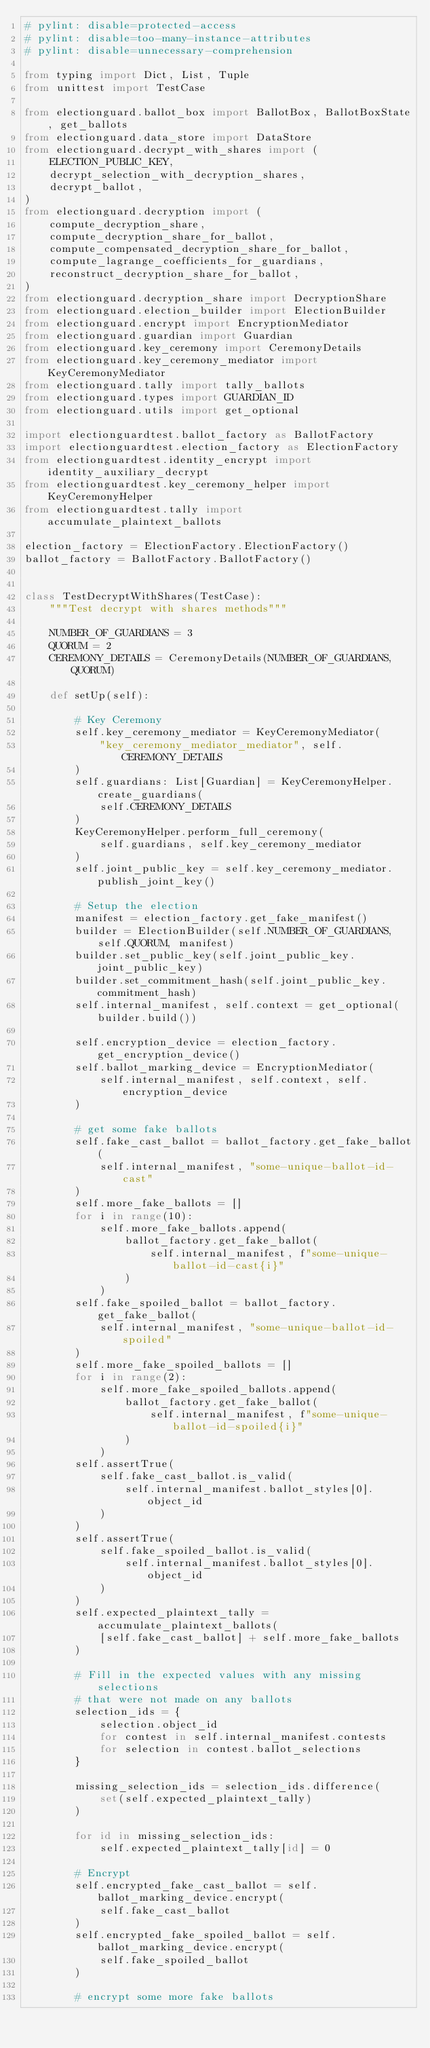<code> <loc_0><loc_0><loc_500><loc_500><_Python_># pylint: disable=protected-access
# pylint: disable=too-many-instance-attributes
# pylint: disable=unnecessary-comprehension

from typing import Dict, List, Tuple
from unittest import TestCase

from electionguard.ballot_box import BallotBox, BallotBoxState, get_ballots
from electionguard.data_store import DataStore
from electionguard.decrypt_with_shares import (
    ELECTION_PUBLIC_KEY,
    decrypt_selection_with_decryption_shares,
    decrypt_ballot,
)
from electionguard.decryption import (
    compute_decryption_share,
    compute_decryption_share_for_ballot,
    compute_compensated_decryption_share_for_ballot,
    compute_lagrange_coefficients_for_guardians,
    reconstruct_decryption_share_for_ballot,
)
from electionguard.decryption_share import DecryptionShare
from electionguard.election_builder import ElectionBuilder
from electionguard.encrypt import EncryptionMediator
from electionguard.guardian import Guardian
from electionguard.key_ceremony import CeremonyDetails
from electionguard.key_ceremony_mediator import KeyCeremonyMediator
from electionguard.tally import tally_ballots
from electionguard.types import GUARDIAN_ID
from electionguard.utils import get_optional

import electionguardtest.ballot_factory as BallotFactory
import electionguardtest.election_factory as ElectionFactory
from electionguardtest.identity_encrypt import identity_auxiliary_decrypt
from electionguardtest.key_ceremony_helper import KeyCeremonyHelper
from electionguardtest.tally import accumulate_plaintext_ballots

election_factory = ElectionFactory.ElectionFactory()
ballot_factory = BallotFactory.BallotFactory()


class TestDecryptWithShares(TestCase):
    """Test decrypt with shares methods"""

    NUMBER_OF_GUARDIANS = 3
    QUORUM = 2
    CEREMONY_DETAILS = CeremonyDetails(NUMBER_OF_GUARDIANS, QUORUM)

    def setUp(self):

        # Key Ceremony
        self.key_ceremony_mediator = KeyCeremonyMediator(
            "key_ceremony_mediator_mediator", self.CEREMONY_DETAILS
        )
        self.guardians: List[Guardian] = KeyCeremonyHelper.create_guardians(
            self.CEREMONY_DETAILS
        )
        KeyCeremonyHelper.perform_full_ceremony(
            self.guardians, self.key_ceremony_mediator
        )
        self.joint_public_key = self.key_ceremony_mediator.publish_joint_key()

        # Setup the election
        manifest = election_factory.get_fake_manifest()
        builder = ElectionBuilder(self.NUMBER_OF_GUARDIANS, self.QUORUM, manifest)
        builder.set_public_key(self.joint_public_key.joint_public_key)
        builder.set_commitment_hash(self.joint_public_key.commitment_hash)
        self.internal_manifest, self.context = get_optional(builder.build())

        self.encryption_device = election_factory.get_encryption_device()
        self.ballot_marking_device = EncryptionMediator(
            self.internal_manifest, self.context, self.encryption_device
        )

        # get some fake ballots
        self.fake_cast_ballot = ballot_factory.get_fake_ballot(
            self.internal_manifest, "some-unique-ballot-id-cast"
        )
        self.more_fake_ballots = []
        for i in range(10):
            self.more_fake_ballots.append(
                ballot_factory.get_fake_ballot(
                    self.internal_manifest, f"some-unique-ballot-id-cast{i}"
                )
            )
        self.fake_spoiled_ballot = ballot_factory.get_fake_ballot(
            self.internal_manifest, "some-unique-ballot-id-spoiled"
        )
        self.more_fake_spoiled_ballots = []
        for i in range(2):
            self.more_fake_spoiled_ballots.append(
                ballot_factory.get_fake_ballot(
                    self.internal_manifest, f"some-unique-ballot-id-spoiled{i}"
                )
            )
        self.assertTrue(
            self.fake_cast_ballot.is_valid(
                self.internal_manifest.ballot_styles[0].object_id
            )
        )
        self.assertTrue(
            self.fake_spoiled_ballot.is_valid(
                self.internal_manifest.ballot_styles[0].object_id
            )
        )
        self.expected_plaintext_tally = accumulate_plaintext_ballots(
            [self.fake_cast_ballot] + self.more_fake_ballots
        )

        # Fill in the expected values with any missing selections
        # that were not made on any ballots
        selection_ids = {
            selection.object_id
            for contest in self.internal_manifest.contests
            for selection in contest.ballot_selections
        }

        missing_selection_ids = selection_ids.difference(
            set(self.expected_plaintext_tally)
        )

        for id in missing_selection_ids:
            self.expected_plaintext_tally[id] = 0

        # Encrypt
        self.encrypted_fake_cast_ballot = self.ballot_marking_device.encrypt(
            self.fake_cast_ballot
        )
        self.encrypted_fake_spoiled_ballot = self.ballot_marking_device.encrypt(
            self.fake_spoiled_ballot
        )

        # encrypt some more fake ballots</code> 